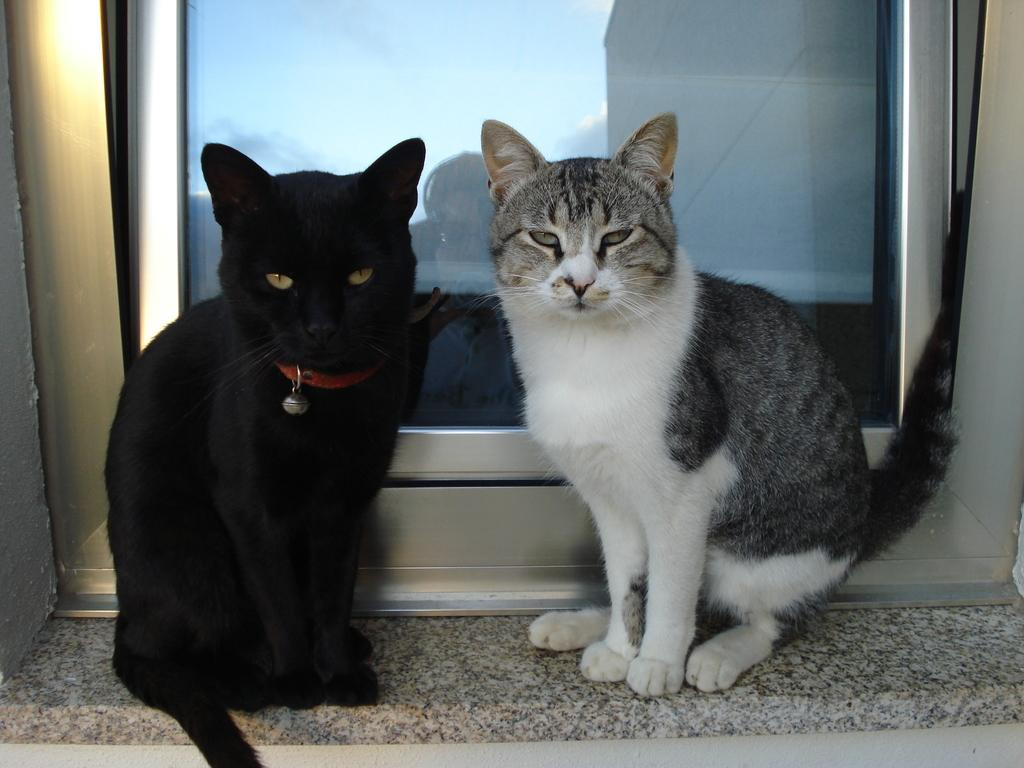How many cats are in the image? There are two cats in the image. Where are the cats located? The cats are sitting on a window shelf. What can be seen in the background of the image? There is a window in the background of the image. Can you describe anything unusual about the window? Yes, there is a reflection of a person on the window glass. What type of yak can be seen grazing in the background of the image? There is no yak present in the image; it features two cats sitting on a window shelf and a window with a person's reflection. 